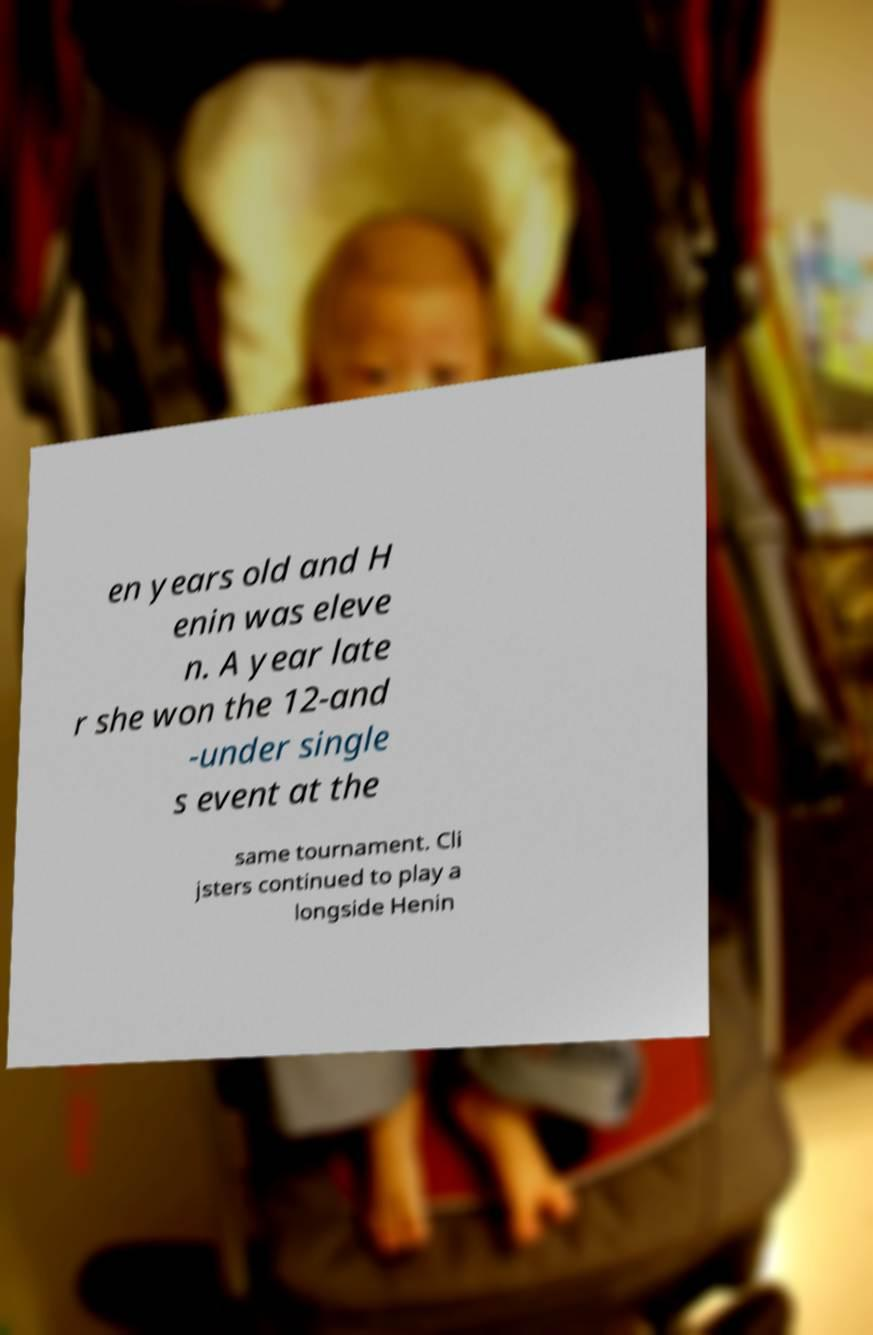Please identify and transcribe the text found in this image. en years old and H enin was eleve n. A year late r she won the 12-and -under single s event at the same tournament. Cli jsters continued to play a longside Henin 